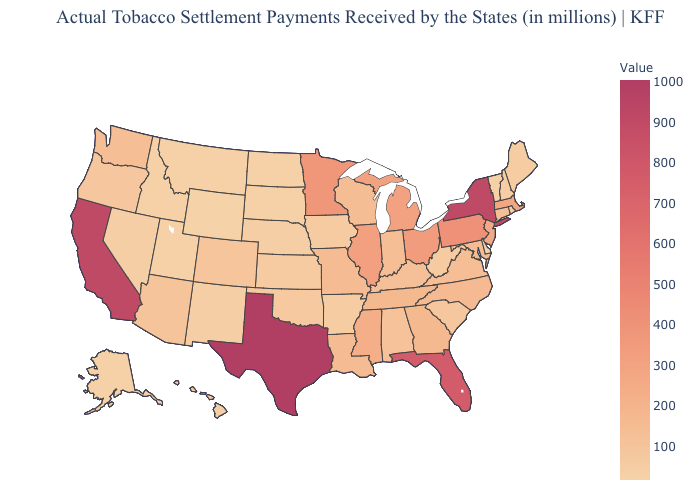Is the legend a continuous bar?
Quick response, please. Yes. Does Alaska have the highest value in the West?
Short answer required. No. Does the map have missing data?
Give a very brief answer. No. Which states have the lowest value in the Northeast?
Give a very brief answer. Vermont. Does Wyoming have the lowest value in the USA?
Short answer required. Yes. Among the states that border Florida , which have the highest value?
Quick response, please. Georgia. Which states have the lowest value in the South?
Give a very brief answer. Delaware. 